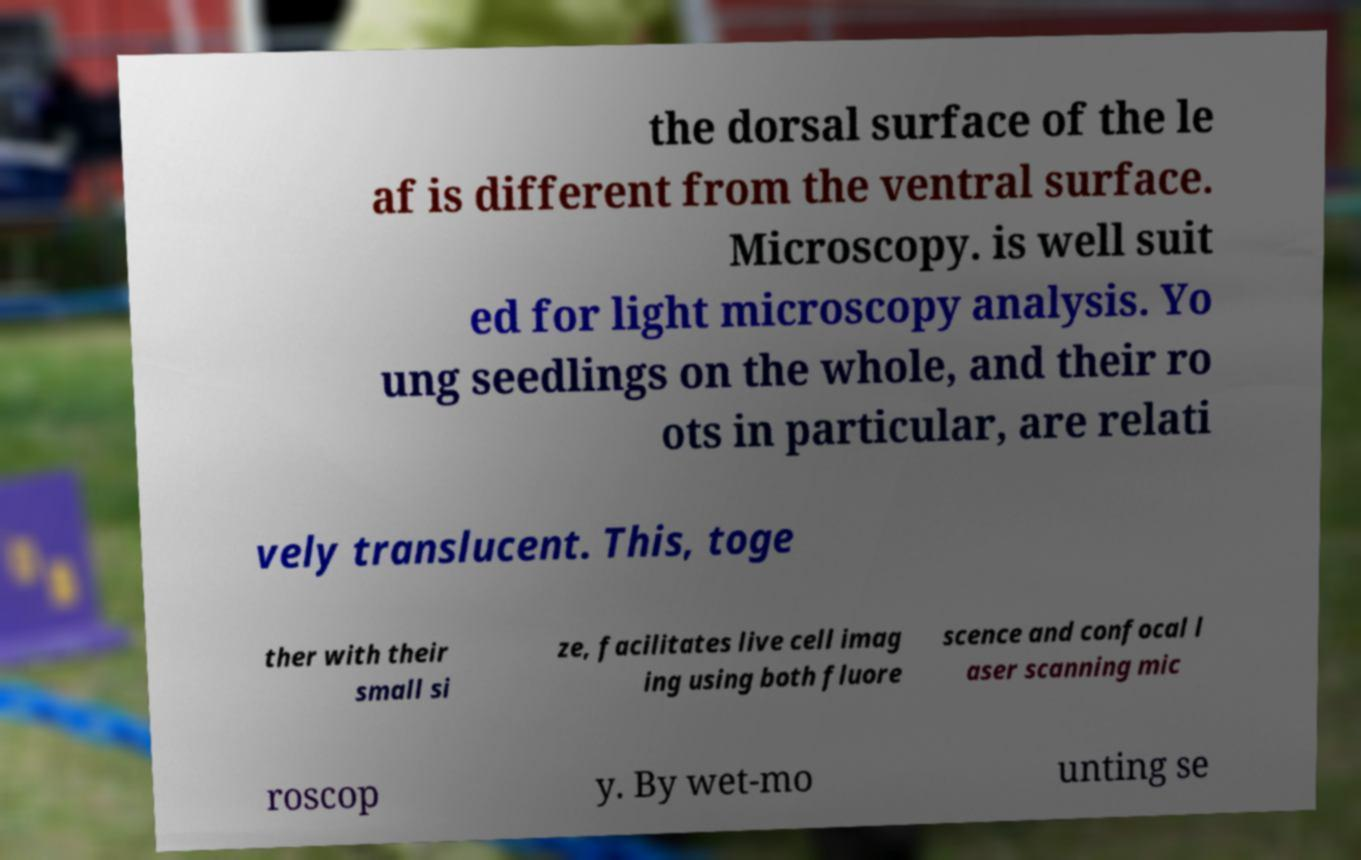There's text embedded in this image that I need extracted. Can you transcribe it verbatim? the dorsal surface of the le af is different from the ventral surface. Microscopy. is well suit ed for light microscopy analysis. Yo ung seedlings on the whole, and their ro ots in particular, are relati vely translucent. This, toge ther with their small si ze, facilitates live cell imag ing using both fluore scence and confocal l aser scanning mic roscop y. By wet-mo unting se 